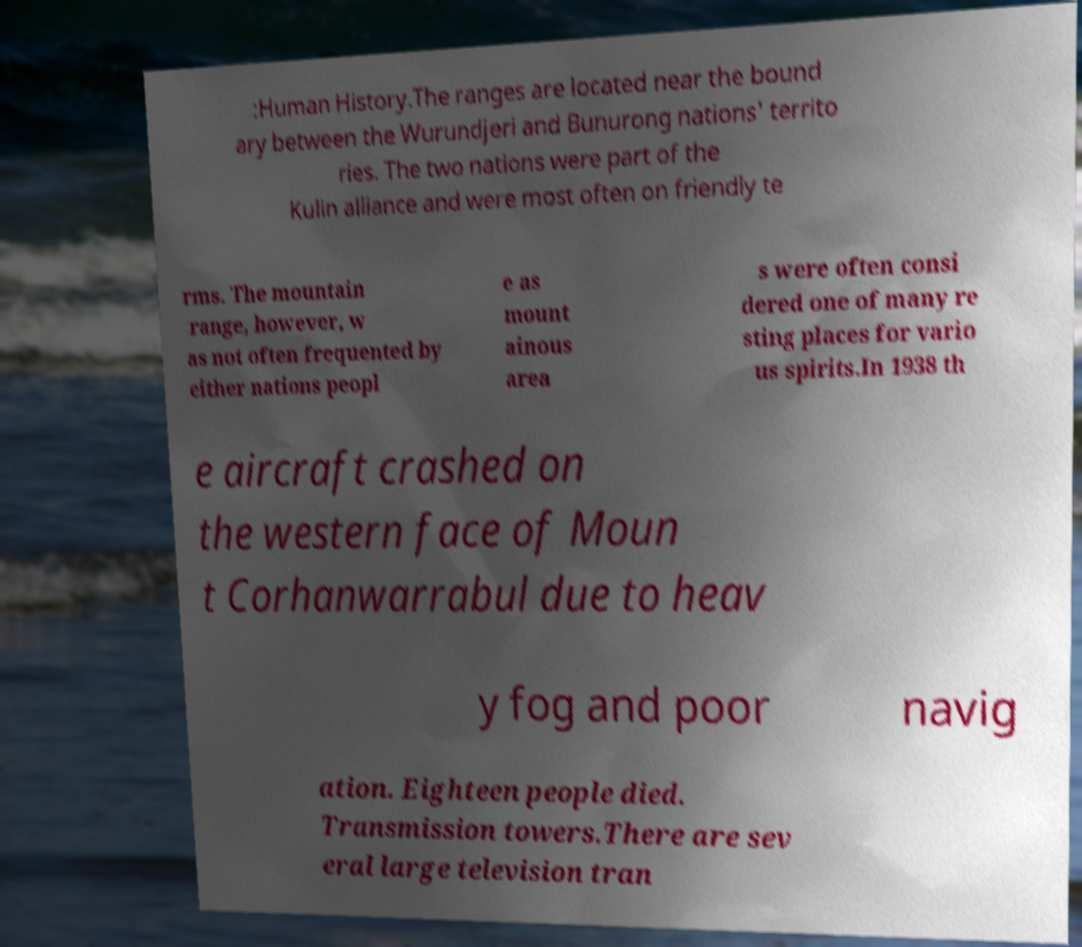Could you assist in decoding the text presented in this image and type it out clearly? :Human History.The ranges are located near the bound ary between the Wurundjeri and Bunurong nations' territo ries. The two nations were part of the Kulin alliance and were most often on friendly te rms. The mountain range, however, w as not often frequented by either nations peopl e as mount ainous area s were often consi dered one of many re sting places for vario us spirits.In 1938 th e aircraft crashed on the western face of Moun t Corhanwarrabul due to heav y fog and poor navig ation. Eighteen people died. Transmission towers.There are sev eral large television tran 